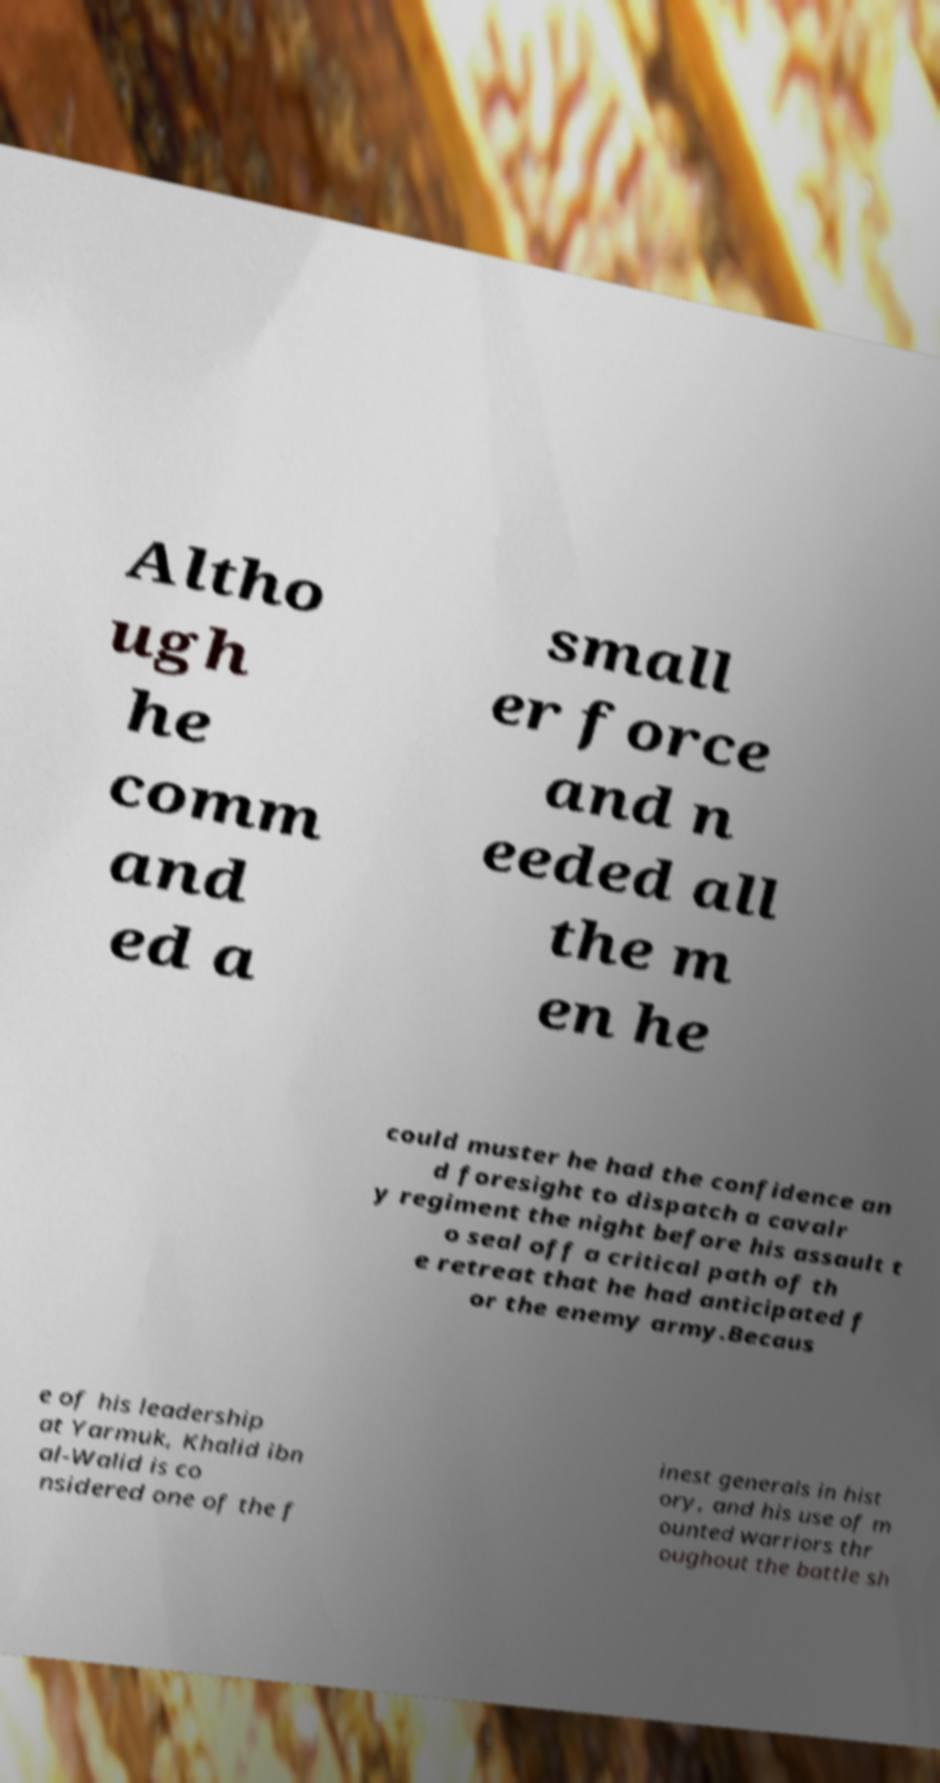For documentation purposes, I need the text within this image transcribed. Could you provide that? Altho ugh he comm and ed a small er force and n eeded all the m en he could muster he had the confidence an d foresight to dispatch a cavalr y regiment the night before his assault t o seal off a critical path of th e retreat that he had anticipated f or the enemy army.Becaus e of his leadership at Yarmuk, Khalid ibn al-Walid is co nsidered one of the f inest generals in hist ory, and his use of m ounted warriors thr oughout the battle sh 